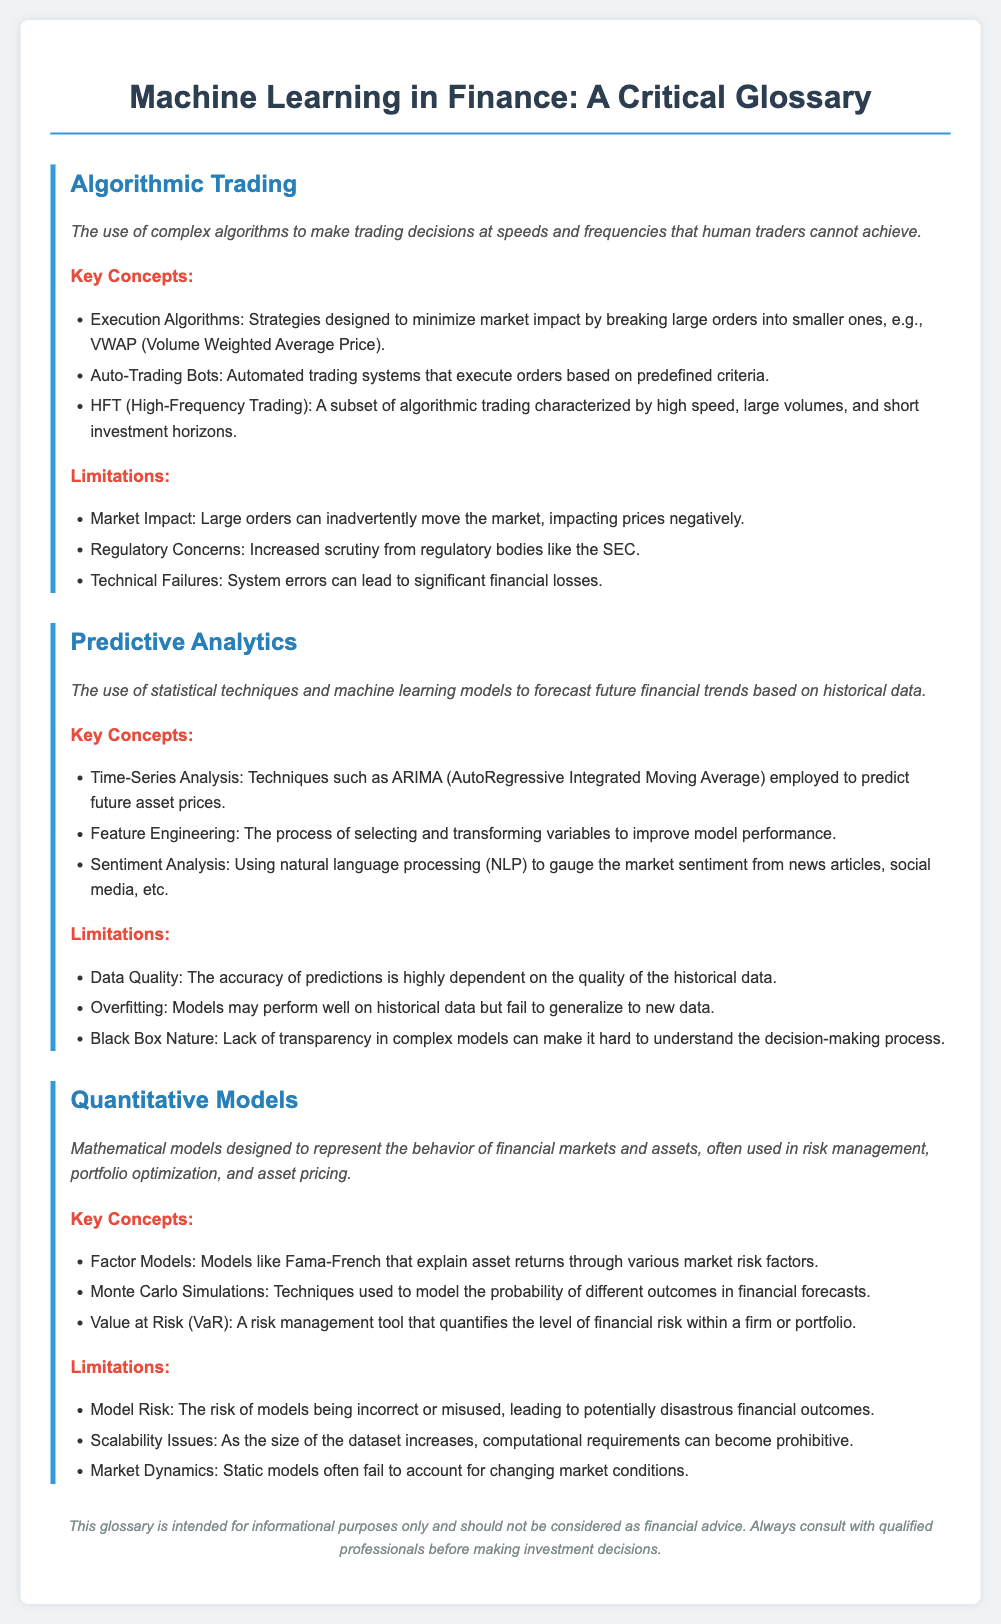What is the definition of Algorithmic Trading? The definition of Algorithmic Trading is the use of complex algorithms to make trading decisions at speeds and frequencies that human traders cannot achieve.
Answer: use of complex algorithms to make trading decisions at speeds and frequencies that human traders cannot achieve What does HFT stand for? HFT stands for High-Frequency Trading, which is a subset of algorithmic trading characterized by high speed, large volumes, and short investment horizons.
Answer: High-Frequency Trading What is the major concern regarding Predictive Analytics? The limitations section mentions that data quality is a major concern since the accuracy of predictions is highly dependent on the quality of the historical data.
Answer: Data Quality What technique is used in Time-Series Analysis? ARIMA (AutoRegressive Integrated Moving Average) is mentioned as a technique employed in Time-Series Analysis to predict future asset prices.
Answer: ARIMA What does VaR represent in Quantitative Models? VaR stands for Value at Risk, which is a risk management tool that quantifies the level of financial risk within a firm or portfolio.
Answer: Value at Risk What are the limitations related to Quantitative Models? The limitations of Quantitative Models include Model Risk, Scalability Issues, and Market Dynamics, highlighting the complexities involved in their application.
Answer: Model Risk, Scalability Issues, Market Dynamics What is a notable issue when using predictive analytics? Overfitting is noted as a limitation, where models may perform well on historical data but fail to generalize to new data.
Answer: Overfitting What does the term "Black Box Nature" refer to? Black Box Nature refers to the lack of transparency in complex models, making it hard to understand the decision-making process involved.
Answer: lack of transparency in complex models 